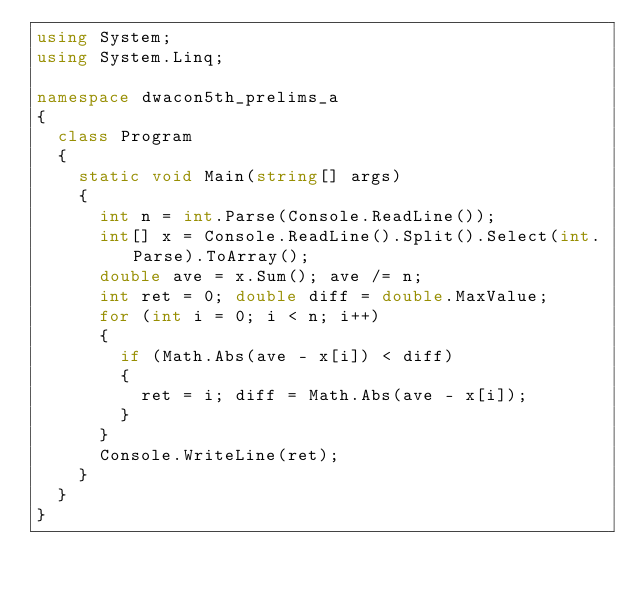Convert code to text. <code><loc_0><loc_0><loc_500><loc_500><_C#_>using System;
using System.Linq;

namespace dwacon5th_prelims_a
{
	class Program
	{
		static void Main(string[] args)
		{
			int n = int.Parse(Console.ReadLine());
			int[] x = Console.ReadLine().Split().Select(int.Parse).ToArray();
			double ave = x.Sum(); ave /= n;
			int ret = 0; double diff = double.MaxValue;
			for (int i = 0; i < n; i++)
			{
				if (Math.Abs(ave - x[i]) < diff)
				{
					ret = i; diff = Math.Abs(ave - x[i]);
				}
			}
			Console.WriteLine(ret);
		}
	}
}</code> 